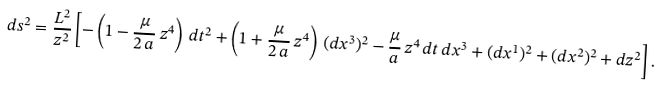<formula> <loc_0><loc_0><loc_500><loc_500>d s ^ { 2 } = \frac { L ^ { 2 } } { z ^ { 2 } } \left [ - \left ( 1 - \frac { \mu } { 2 \, a } \, z ^ { 4 } \right ) \, d t ^ { 2 } + \left ( 1 + \frac { \mu } { 2 \, a } \, z ^ { 4 } \right ) \, ( d x ^ { 3 } ) ^ { 2 } - \frac { \mu } { a } \, z ^ { 4 } \, d t \, d x ^ { 3 } + ( d x ^ { 1 } ) ^ { 2 } + ( d x ^ { 2 } ) ^ { 2 } + d z ^ { 2 } \right ] .</formula> 